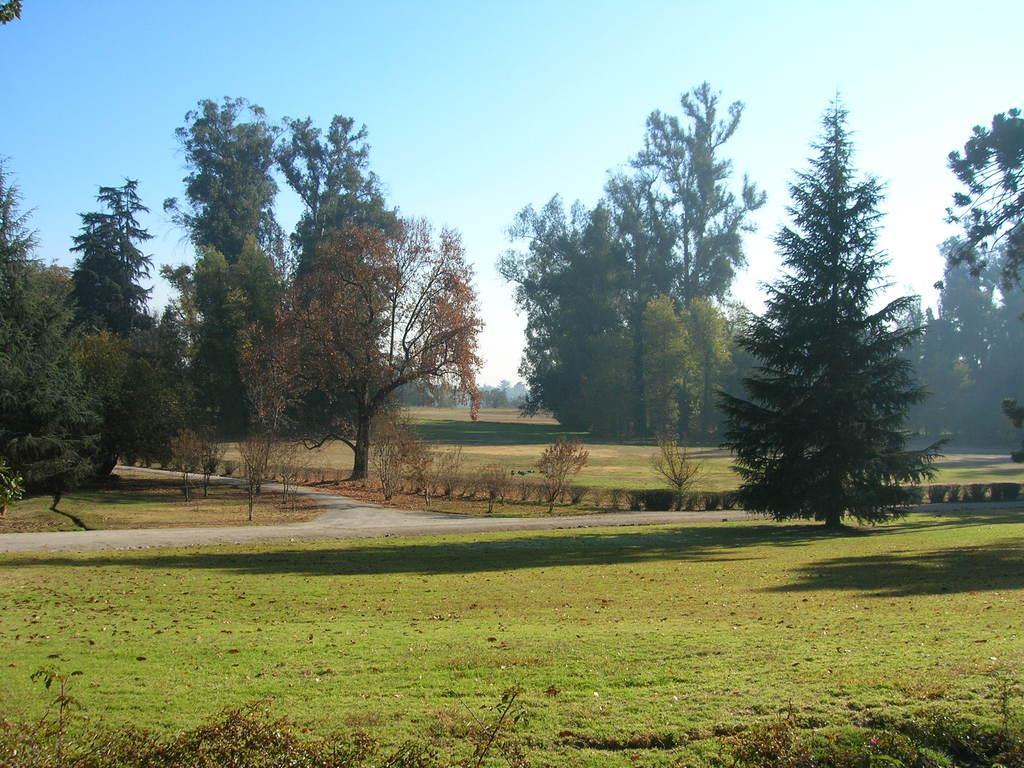In one or two sentences, can you explain what this image depicts? This picture is clicked outside. In the foreground we can see the green grass. In the center we can see the plants and the trees. In the background there is a sky. 